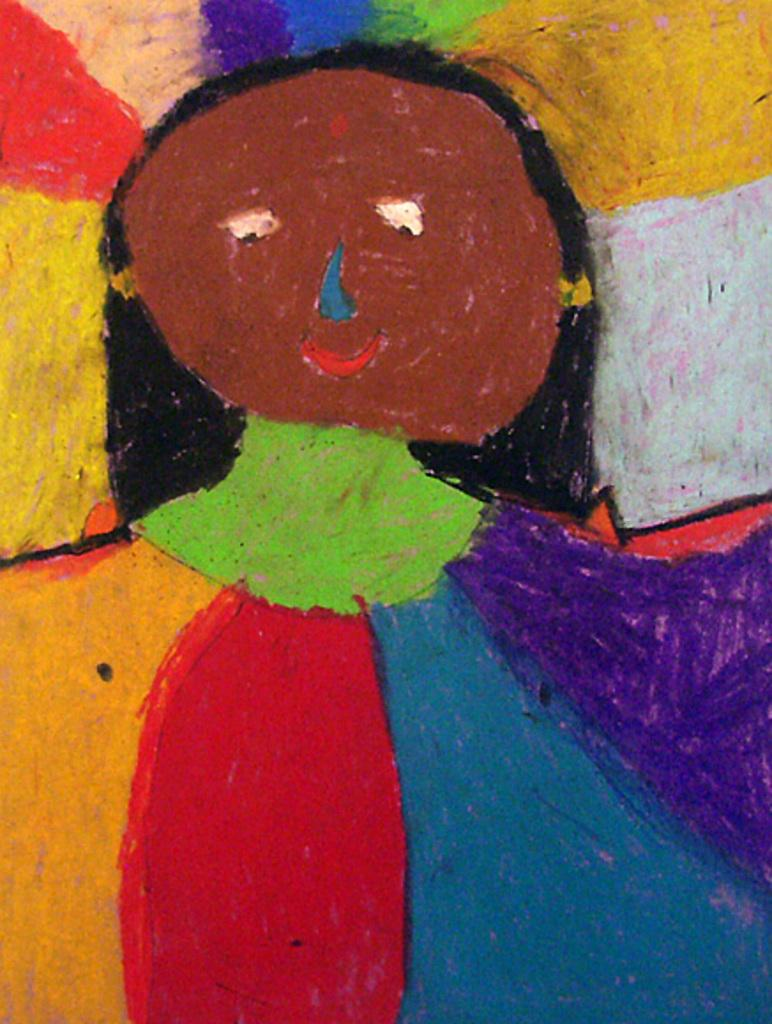What is the main subject of the image? There is a painting in the image. How many sacks are being carried by the man in the painting? There is no man or sacks present in the image, as it only features a painting. 